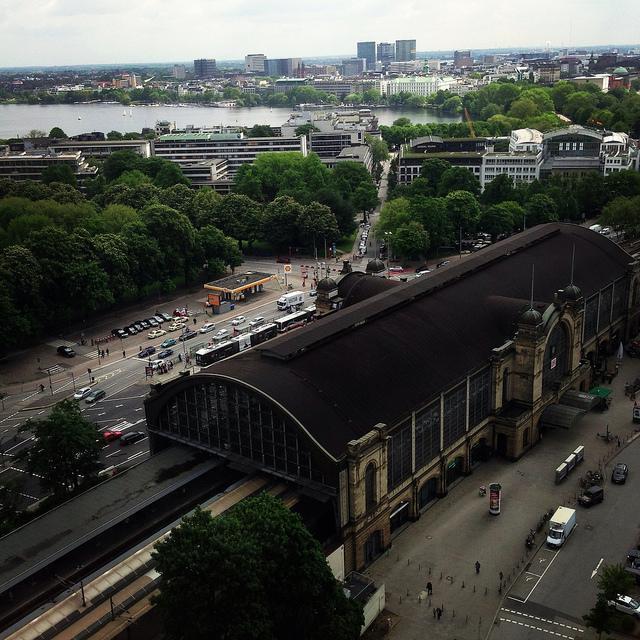The orange rimmed building probable sells which of these products?
Pick the correct solution from the four options below to address the question.
Options: Shoes, gas, flowers, televisions. Gas. 